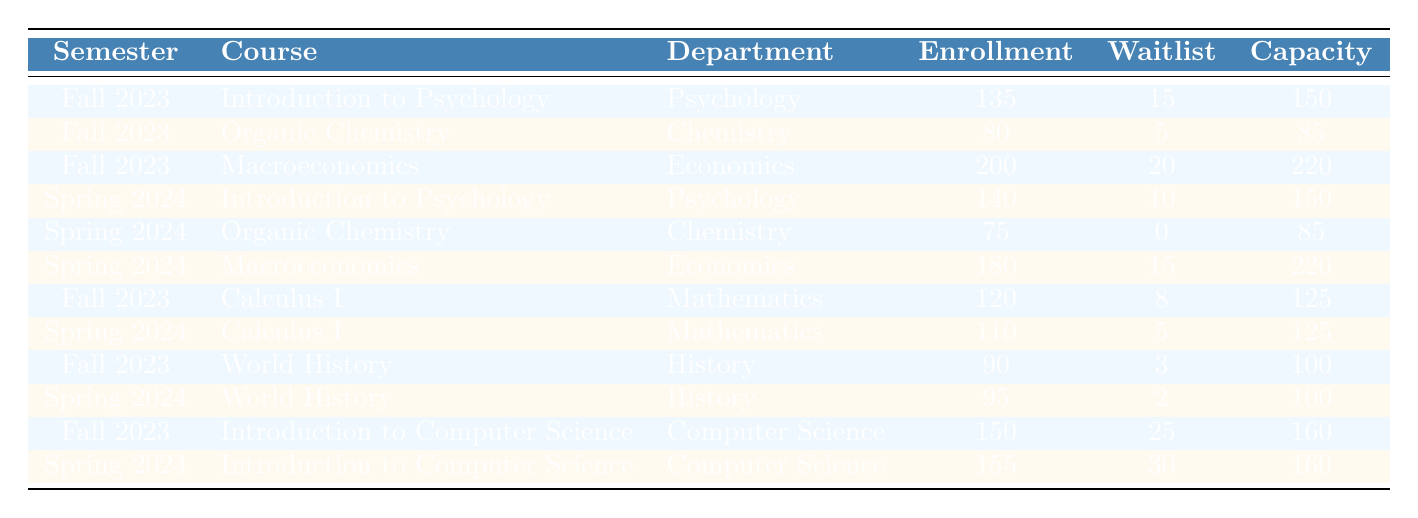What is the highest enrollment for a course in Fall 2023? The highest enrollment in Fall 2023 can be found by checking the Enrollment column for the semester "Fall 2023". The maximum value is 200, which corresponds to the course Macroeconomics.
Answer: 200 How many total students are enrolled across all courses in Spring 2024? To find the total enrollment for Spring 2024, I sum the Enrollment values: 140 (Introduction to Psychology) + 75 (Organic Chemistry) + 180 (Macroeconomics) + 110 (Calculus I) + 95 (World History) + 155 (Introduction to Computer Science) = 755.
Answer: 755 Is there any course on the waitlist in Spring 2024? Checking the Waitlist column for Spring 2024, I see that Organic Chemistry has a waitlist of 0, Calculus I has 5, World History has 2, and Introduction to Computer Science has 30. Since there are non-zero values (5, 2, and 30), the answer is yes.
Answer: Yes Which course had the largest increase in enrollment from Fall 2023 to Spring 2024? To find the course with the largest increase, I calculate the differences in enrollment for each course that appears in both semesters: Introduction to Psychology: 140 - 135 = 5, Organic Chemistry: 75 - 80 = -5, Macroeconomics: 180 - 200 = -20, Calculus I: 110 - 120 = -10, World History: 95 - 90 = 5, Introduction to Computer Science: 155 - 150 = 5. The maximum increase is for Introduction to Psychology, World History, and Introduction to Computer Science, each with an increase of 5.
Answer: Introduction to Psychology, World History, and Introduction to Computer Science What is the enrollment trend for Introduction to Computer Science over the two semesters? The enrollment for Introduction to Computer Science is 150 in Fall 2023 and increases to 155 in Spring 2024. This indicates a positive trend in enrollment for this course.
Answer: Positive trend How many seats are filled, on average, for all courses in Fall 2023? To find the average number of filled seats in Fall 2023, I first calculate the total enrollment for the semester, which is 135 + 80 + 200 + 120 + 90 + 150 = 975. Then, I divide by the number of courses (6), so 975 / 6 = 162.5.
Answer: 162.5 Which department had the least number of enrollments in Spring 2024? To determine which department had the least enrollment in Spring 2024, I look at the Enrollment values for each department: Psychology (140), Chemistry (75), Economics (180), Mathematics (110), History (95), and Computer Science (155). The least is 75, which is from Chemistry.
Answer: Chemistry Was there ever a course with a higher waitlist than enrollment for any semester? Looking at the table for waitlist numbers compared to enrollments: In Fall 2023, Introduction to Computer Science has a waitlist of 25, which is lower than its enrollment of 150; none of the other courses have a higher waitlist than enrollment either. In Spring 2024, the highest waitlist is 30 with an enrollment of 155, which is also lower. Hence, there is no course with a waitlist higher than enrollment.
Answer: No 